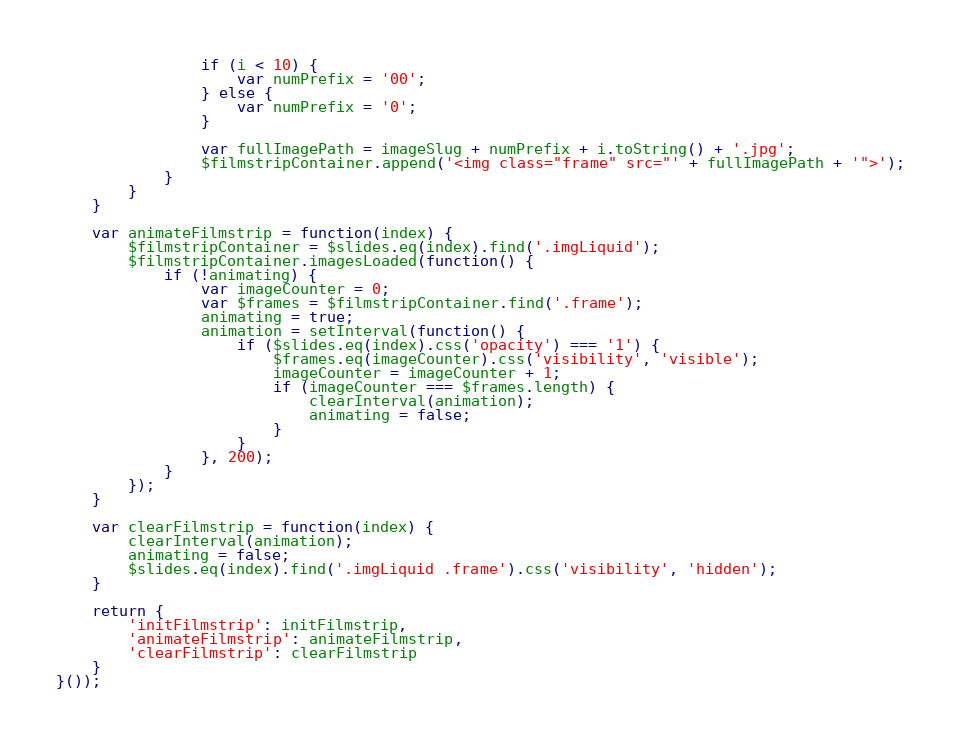Convert code to text. <code><loc_0><loc_0><loc_500><loc_500><_JavaScript_>                if (i < 10) {
                    var numPrefix = '00';
                } else {
                    var numPrefix = '0';
                }

                var fullImagePath = imageSlug + numPrefix + i.toString() + '.jpg';
                $filmstripContainer.append('<img class="frame" src="' + fullImagePath + '">');
            }
        }
    }

    var animateFilmstrip = function(index) {
        $filmstripContainer = $slides.eq(index).find('.imgLiquid');
        $filmstripContainer.imagesLoaded(function() {
            if (!animating) {
                var imageCounter = 0;
                var $frames = $filmstripContainer.find('.frame');
                animating = true;
                animation = setInterval(function() {
                    if ($slides.eq(index).css('opacity') === '1') {
                        $frames.eq(imageCounter).css('visibility', 'visible');
                        imageCounter = imageCounter + 1;
                        if (imageCounter === $frames.length) {
                            clearInterval(animation);
                            animating = false;
                        }
                    }
                }, 200);
            }
        });
    }

    var clearFilmstrip = function(index) {
        clearInterval(animation);
        animating = false;
        $slides.eq(index).find('.imgLiquid .frame').css('visibility', 'hidden');
    }

    return {
        'initFilmstrip': initFilmstrip,
        'animateFilmstrip': animateFilmstrip,
        'clearFilmstrip': clearFilmstrip
    }
}());</code> 